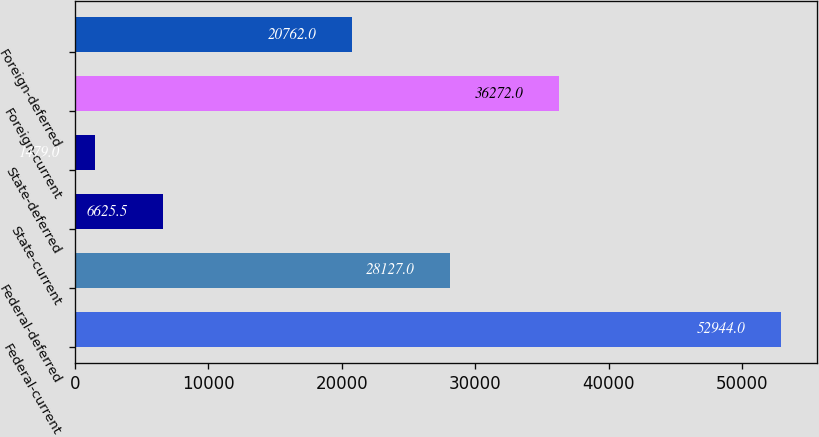<chart> <loc_0><loc_0><loc_500><loc_500><bar_chart><fcel>Federal-current<fcel>Federal-deferred<fcel>State-current<fcel>State-deferred<fcel>Foreign-current<fcel>Foreign-deferred<nl><fcel>52944<fcel>28127<fcel>6625.5<fcel>1479<fcel>36272<fcel>20762<nl></chart> 